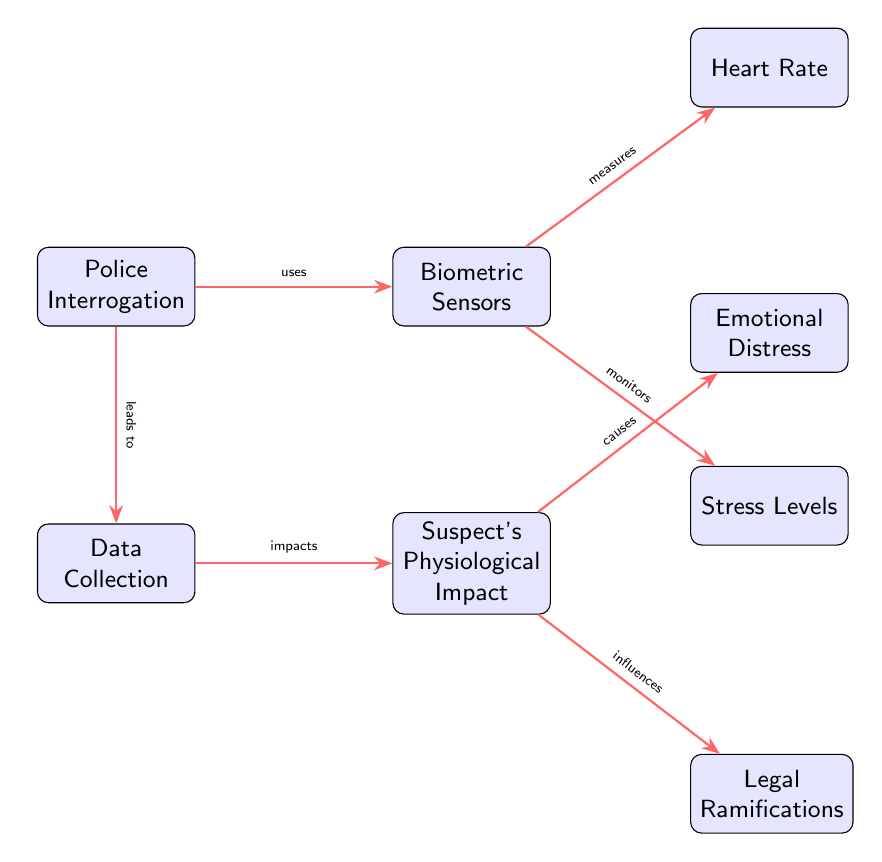What is the first node in the diagram? The first node in the diagram is labeled "Police Interrogation." It is positioned at the top-left corner and represents the starting point of the process illustrated in the diagram.
Answer: Police Interrogation How many biometric sensors are indicated in the diagram? The diagram shows one node specifically labeled "Biometric Sensors," indicating there is one key element of biometric data collection represented.
Answer: One What does "Biometric Sensors" measure? The diagram shows two edges originating from the "Biometric Sensors" node: one going to "Heart Rate," meaning it measures heart rate, and another going to "Stress Levels," indicating it also measures stress levels.
Answer: Heart Rate, Stress Levels What is the physiological impact on the suspect after data collection? The "Suspect's Physiological Impact" node indicates a direct effect following the "Data Collection" process. This node connects to "Emotional Distress" and "Legal Ramifications," showing the physiological consequences inferred by the interrogation.
Answer: Emotional Distress, Legal Ramifications What leads to data collection in the diagram? The diagram shows an edge from "Police Interrogation" to "Data Collection," indicating that the act of interrogation leads to the collection of biometric data.
Answer: Police Interrogation Explain the relationship between "Biometric Sensors" and "Stress Levels." The diagram has an edge connecting "Biometric Sensors" to "Stress Levels," which indicates that the sensors monitor and provide data on the stress levels of the suspect during the interrogation.
Answer: Monitors What causes emotional distress according to the diagram? The arrow from "Suspect's Physiological Impact" to "Emotional Distress" identifies that the physiological impact derived from biometric data collection causes emotional distress in the suspect.
Answer: Physiological Impact What influences legal ramifications in the diagram? The connection from "Suspect's Physiological Impact" to "Legal Ramifications" suggests that the physiological state of the suspect, measured during interrogation, influences potential legal consequences.
Answer: Physiological Impact 